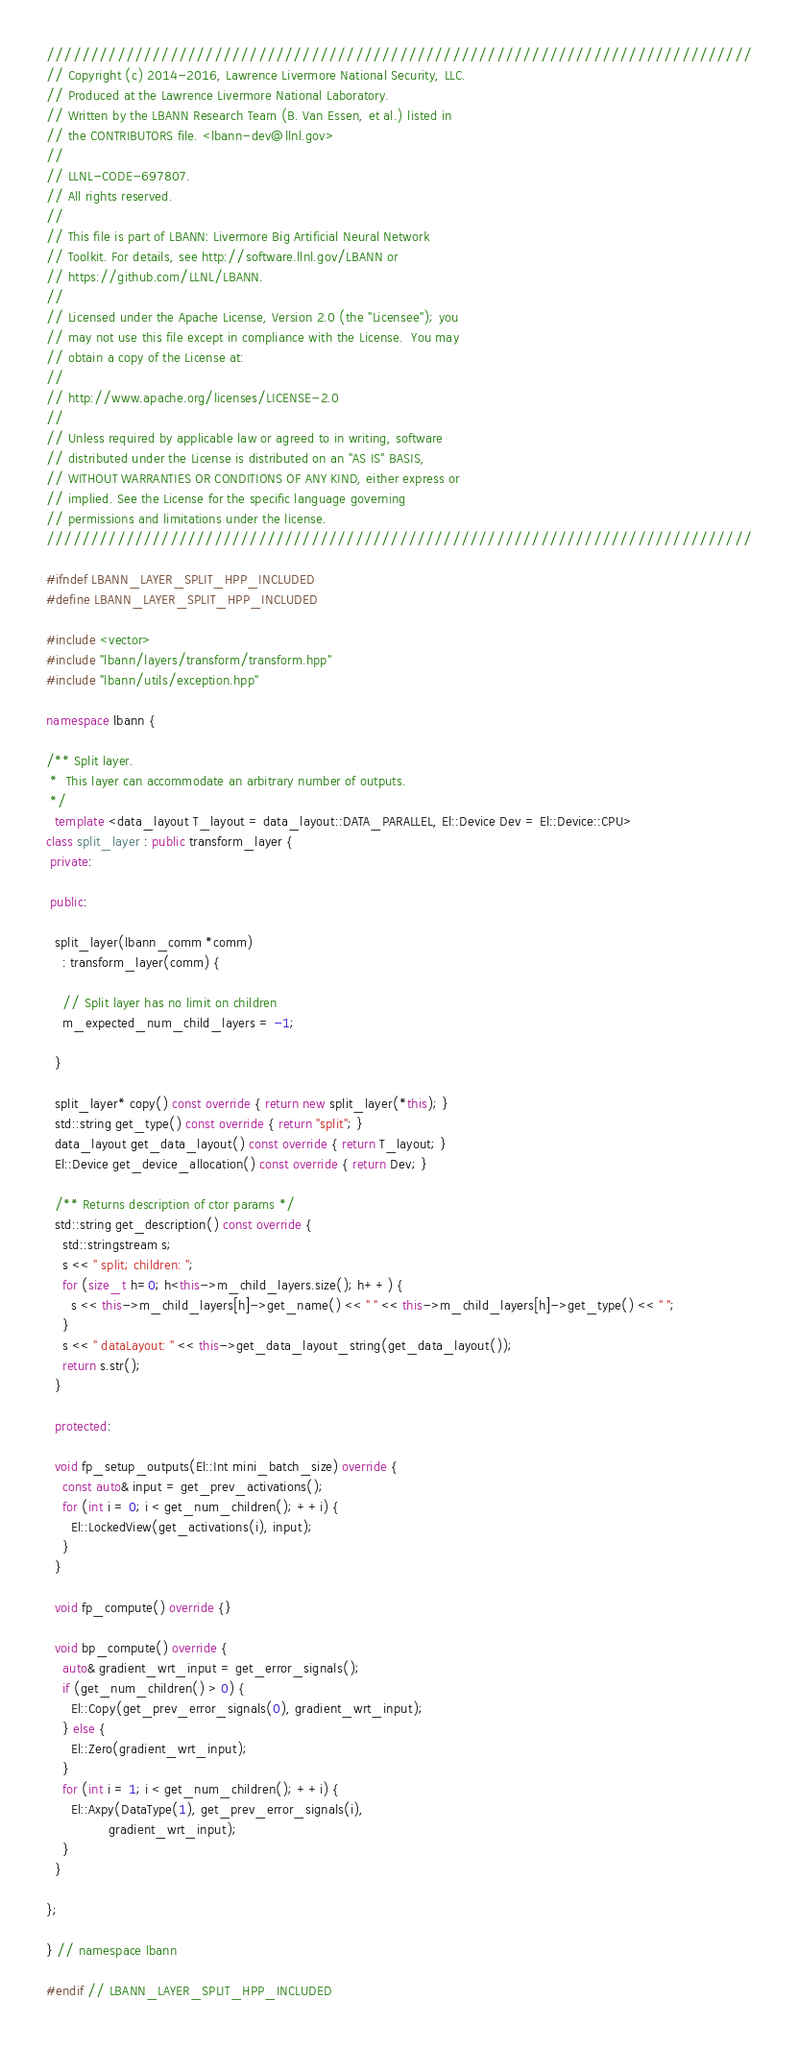<code> <loc_0><loc_0><loc_500><loc_500><_C++_>////////////////////////////////////////////////////////////////////////////////
// Copyright (c) 2014-2016, Lawrence Livermore National Security, LLC.
// Produced at the Lawrence Livermore National Laboratory.
// Written by the LBANN Research Team (B. Van Essen, et al.) listed in
// the CONTRIBUTORS file. <lbann-dev@llnl.gov>
//
// LLNL-CODE-697807.
// All rights reserved.
//
// This file is part of LBANN: Livermore Big Artificial Neural Network
// Toolkit. For details, see http://software.llnl.gov/LBANN or
// https://github.com/LLNL/LBANN.
//
// Licensed under the Apache License, Version 2.0 (the "Licensee"); you
// may not use this file except in compliance with the License.  You may
// obtain a copy of the License at:
//
// http://www.apache.org/licenses/LICENSE-2.0
//
// Unless required by applicable law or agreed to in writing, software
// distributed under the License is distributed on an "AS IS" BASIS,
// WITHOUT WARRANTIES OR CONDITIONS OF ANY KIND, either express or
// implied. See the License for the specific language governing
// permissions and limitations under the license.
////////////////////////////////////////////////////////////////////////////////

#ifndef LBANN_LAYER_SPLIT_HPP_INCLUDED
#define LBANN_LAYER_SPLIT_HPP_INCLUDED

#include <vector>
#include "lbann/layers/transform/transform.hpp"
#include "lbann/utils/exception.hpp"

namespace lbann {

/** Split layer.
 *  This layer can accommodate an arbitrary number of outputs.
 */
  template <data_layout T_layout = data_layout::DATA_PARALLEL, El::Device Dev = El::Device::CPU>
class split_layer : public transform_layer {
 private:

 public:

  split_layer(lbann_comm *comm)
    : transform_layer(comm) {

    // Split layer has no limit on children
    m_expected_num_child_layers = -1;

  }

  split_layer* copy() const override { return new split_layer(*this); }
  std::string get_type() const override { return "split"; }
  data_layout get_data_layout() const override { return T_layout; }
  El::Device get_device_allocation() const override { return Dev; }

  /** Returns description of ctor params */
  std::string get_description() const override {
    std::stringstream s;
    s << " split; children: ";
    for (size_t h=0; h<this->m_child_layers.size(); h++) {
      s << this->m_child_layers[h]->get_name() << " " << this->m_child_layers[h]->get_type() << " ";
    }
    s << " dataLayout: " << this->get_data_layout_string(get_data_layout());
    return s.str();
  }

  protected:

  void fp_setup_outputs(El::Int mini_batch_size) override {
    const auto& input = get_prev_activations();
    for (int i = 0; i < get_num_children(); ++i) {
      El::LockedView(get_activations(i), input);
    }
  }

  void fp_compute() override {}

  void bp_compute() override {
    auto& gradient_wrt_input = get_error_signals();
    if (get_num_children() > 0) {
      El::Copy(get_prev_error_signals(0), gradient_wrt_input);
    } else {
      El::Zero(gradient_wrt_input);
    }
    for (int i = 1; i < get_num_children(); ++i) {
      El::Axpy(DataType(1), get_prev_error_signals(i),
               gradient_wrt_input);
    }
  }

};

} // namespace lbann

#endif // LBANN_LAYER_SPLIT_HPP_INCLUDED
</code> 